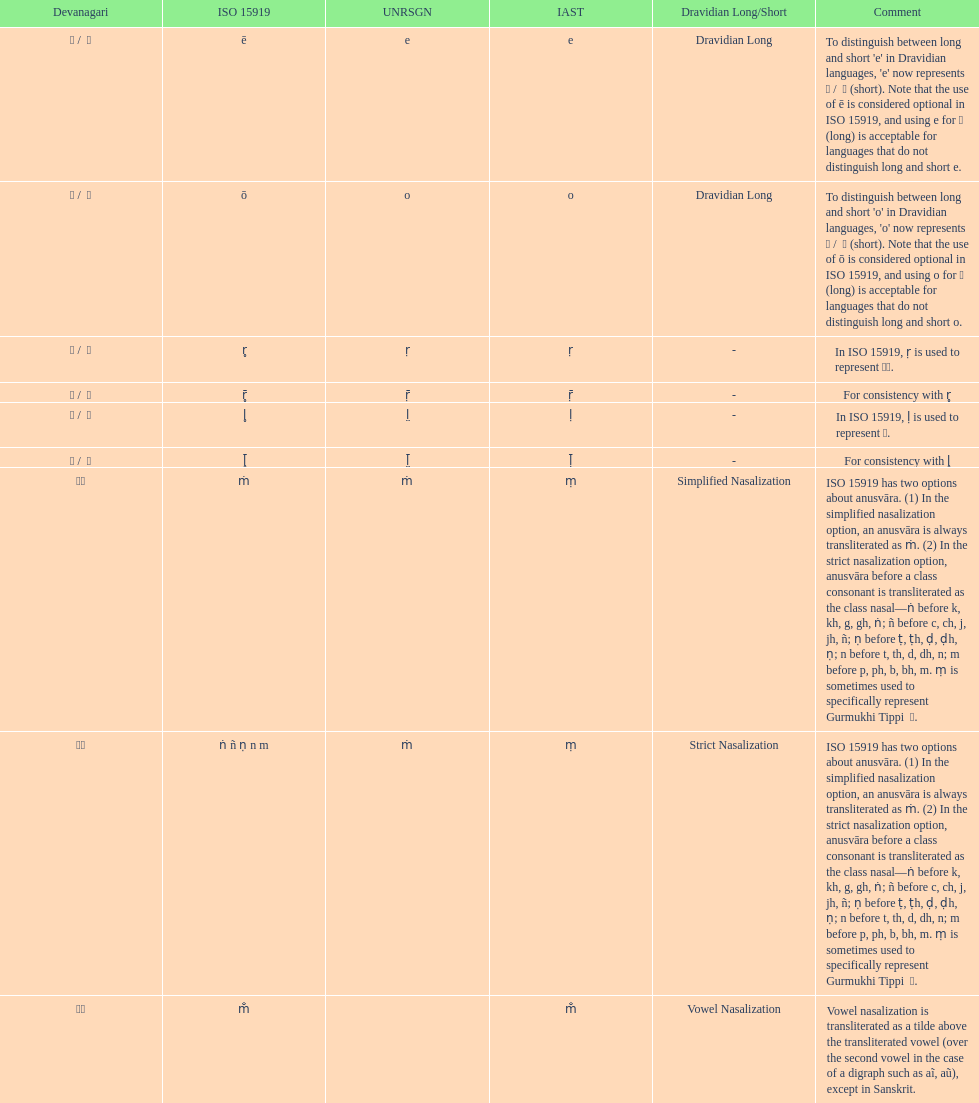Which devanagari symbol corresponds to this iast character: o? ओ / ो. 